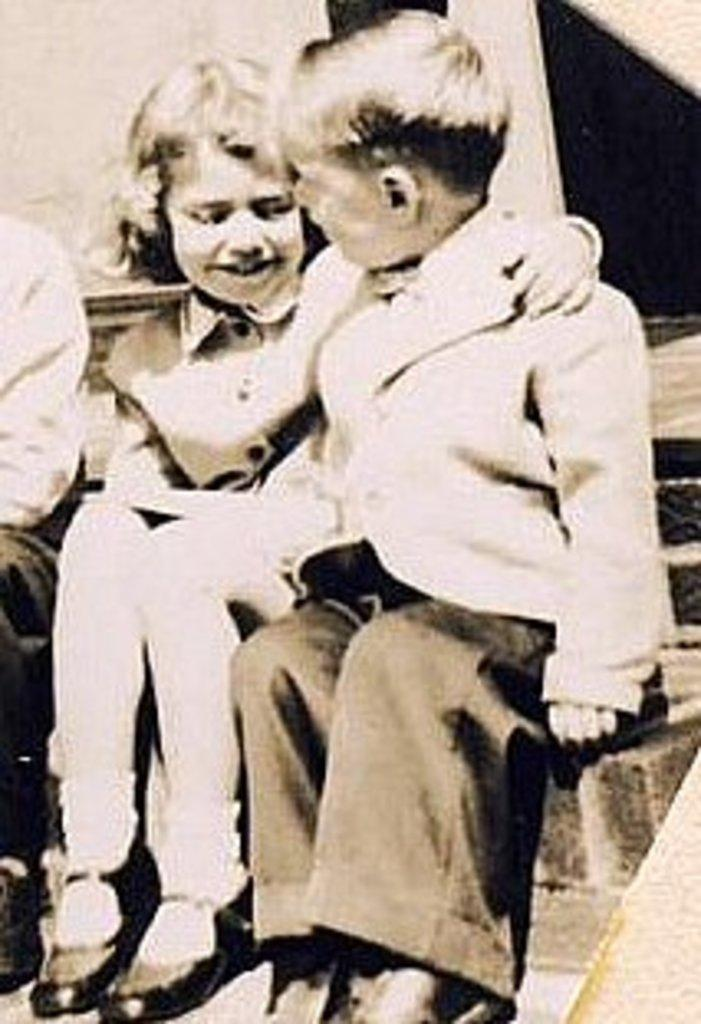How many people are sitting in the image? There are three people sitting in the image. What can be seen behind the people? There is a wall visible behind the people. Can you tell me how far away the dog is from the people in the image? There is no dog present in the image, so it is not possible to determine the distance between a dog and the people. 